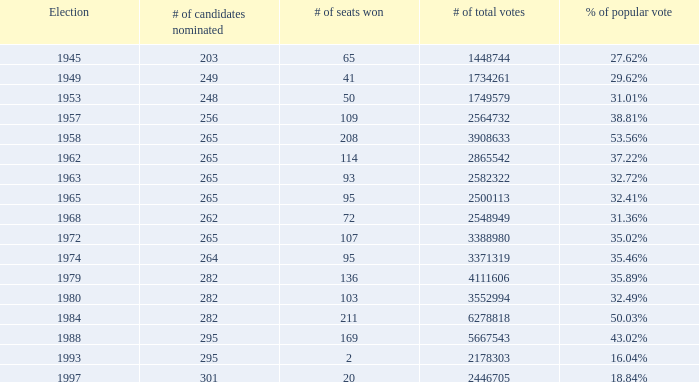How frequently did the total votes reach a count of 2,582,322? 1.0. 